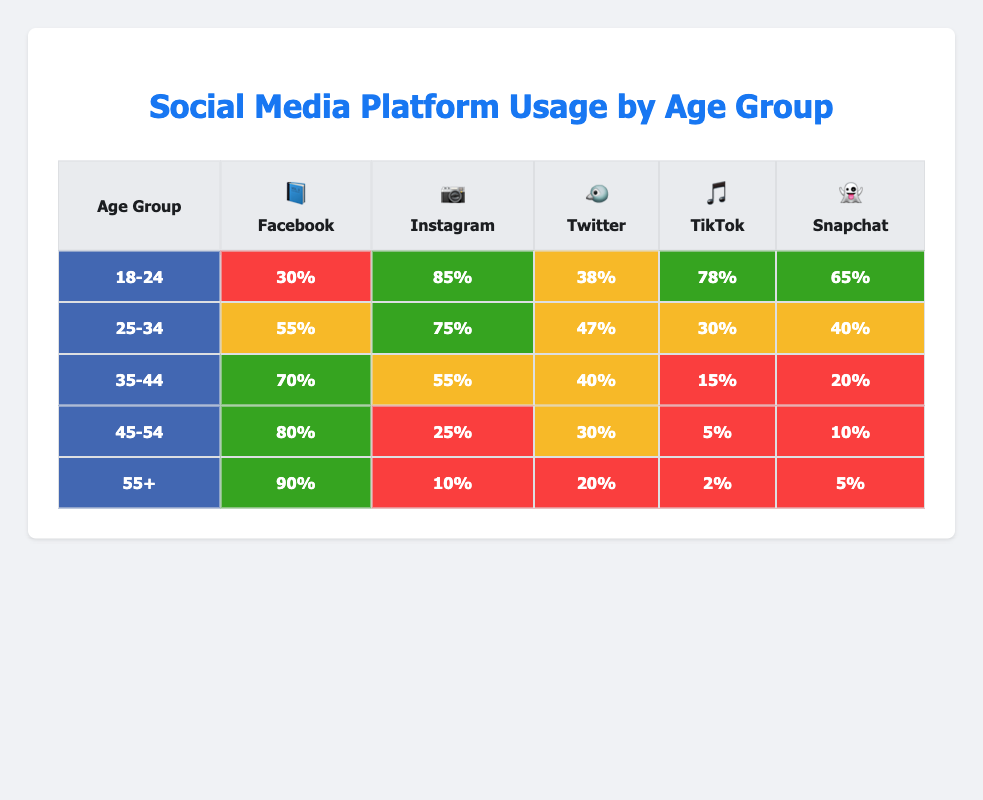What percentage of 18-24 year-olds use Instagram? The table shows that 85% of the 18-24 age group uses Instagram.
Answer: 85% Which age group has the highest usage of Facebook? The table indicates that the 55+ age group has the highest usage of Facebook at 90%.
Answer: 90% What is the average TikTok usage across all age groups? To find the average, sum the TikTok usage percentages for all age groups: (78 + 30 + 15 + 5 + 2) = 130. There are 5 age groups, so the average is 130/5 = 26.
Answer: 26 Is Snapchat usage higher for the 25-34 age group than the 35-44 age group? The table shows Snapchat usage for the 25-34 age group is 40% and for the 35-44 age group is 20%; thus, 40% > 20%, confirming Snapchat usage is higher for 25-34.
Answer: Yes What is the percentage difference in Instagram usage between the 18-24 and 45-54 age groups? Instagram usage for 18-24 is 85% and for 45-54 is 25%. The percentage difference is 85 - 25 = 60%.
Answer: 60% 